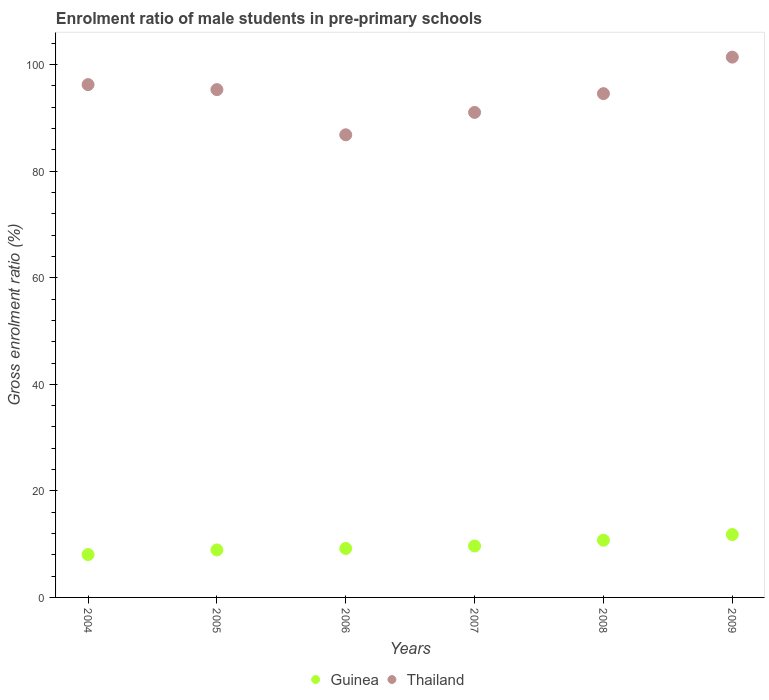How many different coloured dotlines are there?
Provide a short and direct response. 2. What is the enrolment ratio of male students in pre-primary schools in Guinea in 2007?
Offer a terse response. 9.66. Across all years, what is the maximum enrolment ratio of male students in pre-primary schools in Guinea?
Offer a terse response. 11.81. Across all years, what is the minimum enrolment ratio of male students in pre-primary schools in Guinea?
Provide a succinct answer. 8.05. What is the total enrolment ratio of male students in pre-primary schools in Thailand in the graph?
Your answer should be very brief. 565.43. What is the difference between the enrolment ratio of male students in pre-primary schools in Guinea in 2006 and that in 2009?
Offer a terse response. -2.62. What is the difference between the enrolment ratio of male students in pre-primary schools in Guinea in 2004 and the enrolment ratio of male students in pre-primary schools in Thailand in 2007?
Your answer should be compact. -82.99. What is the average enrolment ratio of male students in pre-primary schools in Thailand per year?
Offer a terse response. 94.24. In the year 2007, what is the difference between the enrolment ratio of male students in pre-primary schools in Thailand and enrolment ratio of male students in pre-primary schools in Guinea?
Keep it short and to the point. 81.38. In how many years, is the enrolment ratio of male students in pre-primary schools in Thailand greater than 44 %?
Ensure brevity in your answer.  6. What is the ratio of the enrolment ratio of male students in pre-primary schools in Guinea in 2006 to that in 2008?
Your response must be concise. 0.86. What is the difference between the highest and the second highest enrolment ratio of male students in pre-primary schools in Guinea?
Make the answer very short. 1.07. What is the difference between the highest and the lowest enrolment ratio of male students in pre-primary schools in Guinea?
Offer a terse response. 3.76. Is the enrolment ratio of male students in pre-primary schools in Thailand strictly less than the enrolment ratio of male students in pre-primary schools in Guinea over the years?
Your response must be concise. No. What is the difference between two consecutive major ticks on the Y-axis?
Provide a short and direct response. 20. What is the title of the graph?
Provide a succinct answer. Enrolment ratio of male students in pre-primary schools. What is the label or title of the Y-axis?
Keep it short and to the point. Gross enrolment ratio (%). What is the Gross enrolment ratio (%) in Guinea in 2004?
Provide a short and direct response. 8.05. What is the Gross enrolment ratio (%) of Thailand in 2004?
Provide a succinct answer. 96.26. What is the Gross enrolment ratio (%) in Guinea in 2005?
Provide a succinct answer. 8.92. What is the Gross enrolment ratio (%) in Thailand in 2005?
Your answer should be compact. 95.32. What is the Gross enrolment ratio (%) in Guinea in 2006?
Provide a succinct answer. 9.19. What is the Gross enrolment ratio (%) in Thailand in 2006?
Offer a terse response. 86.84. What is the Gross enrolment ratio (%) in Guinea in 2007?
Provide a short and direct response. 9.66. What is the Gross enrolment ratio (%) in Thailand in 2007?
Offer a very short reply. 91.04. What is the Gross enrolment ratio (%) in Guinea in 2008?
Provide a short and direct response. 10.74. What is the Gross enrolment ratio (%) in Thailand in 2008?
Your answer should be very brief. 94.56. What is the Gross enrolment ratio (%) of Guinea in 2009?
Your answer should be very brief. 11.81. What is the Gross enrolment ratio (%) in Thailand in 2009?
Ensure brevity in your answer.  101.42. Across all years, what is the maximum Gross enrolment ratio (%) in Guinea?
Give a very brief answer. 11.81. Across all years, what is the maximum Gross enrolment ratio (%) of Thailand?
Your answer should be compact. 101.42. Across all years, what is the minimum Gross enrolment ratio (%) of Guinea?
Your answer should be compact. 8.05. Across all years, what is the minimum Gross enrolment ratio (%) of Thailand?
Keep it short and to the point. 86.84. What is the total Gross enrolment ratio (%) in Guinea in the graph?
Your response must be concise. 58.35. What is the total Gross enrolment ratio (%) of Thailand in the graph?
Provide a succinct answer. 565.43. What is the difference between the Gross enrolment ratio (%) of Guinea in 2004 and that in 2005?
Your response must be concise. -0.87. What is the difference between the Gross enrolment ratio (%) in Thailand in 2004 and that in 2005?
Your answer should be compact. 0.94. What is the difference between the Gross enrolment ratio (%) of Guinea in 2004 and that in 2006?
Give a very brief answer. -1.14. What is the difference between the Gross enrolment ratio (%) in Thailand in 2004 and that in 2006?
Your answer should be compact. 9.42. What is the difference between the Gross enrolment ratio (%) in Guinea in 2004 and that in 2007?
Give a very brief answer. -1.61. What is the difference between the Gross enrolment ratio (%) in Thailand in 2004 and that in 2007?
Provide a short and direct response. 5.22. What is the difference between the Gross enrolment ratio (%) of Guinea in 2004 and that in 2008?
Offer a terse response. -2.69. What is the difference between the Gross enrolment ratio (%) of Thailand in 2004 and that in 2008?
Offer a terse response. 1.7. What is the difference between the Gross enrolment ratio (%) in Guinea in 2004 and that in 2009?
Your answer should be very brief. -3.76. What is the difference between the Gross enrolment ratio (%) of Thailand in 2004 and that in 2009?
Ensure brevity in your answer.  -5.16. What is the difference between the Gross enrolment ratio (%) of Guinea in 2005 and that in 2006?
Your answer should be very brief. -0.27. What is the difference between the Gross enrolment ratio (%) of Thailand in 2005 and that in 2006?
Provide a short and direct response. 8.48. What is the difference between the Gross enrolment ratio (%) in Guinea in 2005 and that in 2007?
Ensure brevity in your answer.  -0.74. What is the difference between the Gross enrolment ratio (%) of Thailand in 2005 and that in 2007?
Offer a terse response. 4.28. What is the difference between the Gross enrolment ratio (%) in Guinea in 2005 and that in 2008?
Your answer should be very brief. -1.82. What is the difference between the Gross enrolment ratio (%) of Thailand in 2005 and that in 2008?
Your response must be concise. 0.76. What is the difference between the Gross enrolment ratio (%) in Guinea in 2005 and that in 2009?
Give a very brief answer. -2.89. What is the difference between the Gross enrolment ratio (%) of Thailand in 2005 and that in 2009?
Offer a very short reply. -6.1. What is the difference between the Gross enrolment ratio (%) of Guinea in 2006 and that in 2007?
Keep it short and to the point. -0.47. What is the difference between the Gross enrolment ratio (%) of Thailand in 2006 and that in 2007?
Your answer should be compact. -4.2. What is the difference between the Gross enrolment ratio (%) in Guinea in 2006 and that in 2008?
Keep it short and to the point. -1.55. What is the difference between the Gross enrolment ratio (%) in Thailand in 2006 and that in 2008?
Your answer should be very brief. -7.73. What is the difference between the Gross enrolment ratio (%) in Guinea in 2006 and that in 2009?
Ensure brevity in your answer.  -2.62. What is the difference between the Gross enrolment ratio (%) of Thailand in 2006 and that in 2009?
Offer a very short reply. -14.58. What is the difference between the Gross enrolment ratio (%) of Guinea in 2007 and that in 2008?
Ensure brevity in your answer.  -1.08. What is the difference between the Gross enrolment ratio (%) of Thailand in 2007 and that in 2008?
Keep it short and to the point. -3.52. What is the difference between the Gross enrolment ratio (%) in Guinea in 2007 and that in 2009?
Provide a succinct answer. -2.15. What is the difference between the Gross enrolment ratio (%) of Thailand in 2007 and that in 2009?
Give a very brief answer. -10.38. What is the difference between the Gross enrolment ratio (%) of Guinea in 2008 and that in 2009?
Ensure brevity in your answer.  -1.07. What is the difference between the Gross enrolment ratio (%) of Thailand in 2008 and that in 2009?
Ensure brevity in your answer.  -6.85. What is the difference between the Gross enrolment ratio (%) in Guinea in 2004 and the Gross enrolment ratio (%) in Thailand in 2005?
Provide a succinct answer. -87.27. What is the difference between the Gross enrolment ratio (%) of Guinea in 2004 and the Gross enrolment ratio (%) of Thailand in 2006?
Provide a short and direct response. -78.79. What is the difference between the Gross enrolment ratio (%) in Guinea in 2004 and the Gross enrolment ratio (%) in Thailand in 2007?
Offer a terse response. -82.99. What is the difference between the Gross enrolment ratio (%) in Guinea in 2004 and the Gross enrolment ratio (%) in Thailand in 2008?
Your answer should be very brief. -86.52. What is the difference between the Gross enrolment ratio (%) in Guinea in 2004 and the Gross enrolment ratio (%) in Thailand in 2009?
Your response must be concise. -93.37. What is the difference between the Gross enrolment ratio (%) in Guinea in 2005 and the Gross enrolment ratio (%) in Thailand in 2006?
Your answer should be very brief. -77.92. What is the difference between the Gross enrolment ratio (%) of Guinea in 2005 and the Gross enrolment ratio (%) of Thailand in 2007?
Provide a succinct answer. -82.12. What is the difference between the Gross enrolment ratio (%) in Guinea in 2005 and the Gross enrolment ratio (%) in Thailand in 2008?
Provide a succinct answer. -85.64. What is the difference between the Gross enrolment ratio (%) in Guinea in 2005 and the Gross enrolment ratio (%) in Thailand in 2009?
Your response must be concise. -92.5. What is the difference between the Gross enrolment ratio (%) in Guinea in 2006 and the Gross enrolment ratio (%) in Thailand in 2007?
Provide a short and direct response. -81.85. What is the difference between the Gross enrolment ratio (%) of Guinea in 2006 and the Gross enrolment ratio (%) of Thailand in 2008?
Your response must be concise. -85.38. What is the difference between the Gross enrolment ratio (%) of Guinea in 2006 and the Gross enrolment ratio (%) of Thailand in 2009?
Offer a terse response. -92.23. What is the difference between the Gross enrolment ratio (%) of Guinea in 2007 and the Gross enrolment ratio (%) of Thailand in 2008?
Your answer should be compact. -84.9. What is the difference between the Gross enrolment ratio (%) of Guinea in 2007 and the Gross enrolment ratio (%) of Thailand in 2009?
Provide a succinct answer. -91.76. What is the difference between the Gross enrolment ratio (%) of Guinea in 2008 and the Gross enrolment ratio (%) of Thailand in 2009?
Offer a terse response. -90.68. What is the average Gross enrolment ratio (%) in Guinea per year?
Provide a short and direct response. 9.72. What is the average Gross enrolment ratio (%) in Thailand per year?
Make the answer very short. 94.24. In the year 2004, what is the difference between the Gross enrolment ratio (%) of Guinea and Gross enrolment ratio (%) of Thailand?
Your response must be concise. -88.21. In the year 2005, what is the difference between the Gross enrolment ratio (%) of Guinea and Gross enrolment ratio (%) of Thailand?
Provide a short and direct response. -86.4. In the year 2006, what is the difference between the Gross enrolment ratio (%) of Guinea and Gross enrolment ratio (%) of Thailand?
Your answer should be very brief. -77.65. In the year 2007, what is the difference between the Gross enrolment ratio (%) in Guinea and Gross enrolment ratio (%) in Thailand?
Your response must be concise. -81.38. In the year 2008, what is the difference between the Gross enrolment ratio (%) in Guinea and Gross enrolment ratio (%) in Thailand?
Make the answer very short. -83.82. In the year 2009, what is the difference between the Gross enrolment ratio (%) of Guinea and Gross enrolment ratio (%) of Thailand?
Make the answer very short. -89.61. What is the ratio of the Gross enrolment ratio (%) in Guinea in 2004 to that in 2005?
Ensure brevity in your answer.  0.9. What is the ratio of the Gross enrolment ratio (%) of Thailand in 2004 to that in 2005?
Your answer should be compact. 1.01. What is the ratio of the Gross enrolment ratio (%) of Guinea in 2004 to that in 2006?
Make the answer very short. 0.88. What is the ratio of the Gross enrolment ratio (%) in Thailand in 2004 to that in 2006?
Keep it short and to the point. 1.11. What is the ratio of the Gross enrolment ratio (%) in Guinea in 2004 to that in 2007?
Provide a short and direct response. 0.83. What is the ratio of the Gross enrolment ratio (%) of Thailand in 2004 to that in 2007?
Make the answer very short. 1.06. What is the ratio of the Gross enrolment ratio (%) in Guinea in 2004 to that in 2008?
Provide a short and direct response. 0.75. What is the ratio of the Gross enrolment ratio (%) in Thailand in 2004 to that in 2008?
Offer a terse response. 1.02. What is the ratio of the Gross enrolment ratio (%) in Guinea in 2004 to that in 2009?
Provide a succinct answer. 0.68. What is the ratio of the Gross enrolment ratio (%) in Thailand in 2004 to that in 2009?
Offer a very short reply. 0.95. What is the ratio of the Gross enrolment ratio (%) of Guinea in 2005 to that in 2006?
Provide a succinct answer. 0.97. What is the ratio of the Gross enrolment ratio (%) in Thailand in 2005 to that in 2006?
Keep it short and to the point. 1.1. What is the ratio of the Gross enrolment ratio (%) of Guinea in 2005 to that in 2007?
Offer a terse response. 0.92. What is the ratio of the Gross enrolment ratio (%) of Thailand in 2005 to that in 2007?
Your response must be concise. 1.05. What is the ratio of the Gross enrolment ratio (%) of Guinea in 2005 to that in 2008?
Ensure brevity in your answer.  0.83. What is the ratio of the Gross enrolment ratio (%) of Thailand in 2005 to that in 2008?
Your response must be concise. 1.01. What is the ratio of the Gross enrolment ratio (%) in Guinea in 2005 to that in 2009?
Make the answer very short. 0.76. What is the ratio of the Gross enrolment ratio (%) in Thailand in 2005 to that in 2009?
Provide a succinct answer. 0.94. What is the ratio of the Gross enrolment ratio (%) in Guinea in 2006 to that in 2007?
Offer a very short reply. 0.95. What is the ratio of the Gross enrolment ratio (%) in Thailand in 2006 to that in 2007?
Make the answer very short. 0.95. What is the ratio of the Gross enrolment ratio (%) in Guinea in 2006 to that in 2008?
Your answer should be compact. 0.86. What is the ratio of the Gross enrolment ratio (%) of Thailand in 2006 to that in 2008?
Provide a short and direct response. 0.92. What is the ratio of the Gross enrolment ratio (%) of Guinea in 2006 to that in 2009?
Your response must be concise. 0.78. What is the ratio of the Gross enrolment ratio (%) in Thailand in 2006 to that in 2009?
Offer a very short reply. 0.86. What is the ratio of the Gross enrolment ratio (%) in Guinea in 2007 to that in 2008?
Ensure brevity in your answer.  0.9. What is the ratio of the Gross enrolment ratio (%) of Thailand in 2007 to that in 2008?
Give a very brief answer. 0.96. What is the ratio of the Gross enrolment ratio (%) in Guinea in 2007 to that in 2009?
Provide a short and direct response. 0.82. What is the ratio of the Gross enrolment ratio (%) of Thailand in 2007 to that in 2009?
Make the answer very short. 0.9. What is the ratio of the Gross enrolment ratio (%) in Guinea in 2008 to that in 2009?
Keep it short and to the point. 0.91. What is the ratio of the Gross enrolment ratio (%) of Thailand in 2008 to that in 2009?
Your answer should be very brief. 0.93. What is the difference between the highest and the second highest Gross enrolment ratio (%) in Guinea?
Ensure brevity in your answer.  1.07. What is the difference between the highest and the second highest Gross enrolment ratio (%) of Thailand?
Make the answer very short. 5.16. What is the difference between the highest and the lowest Gross enrolment ratio (%) in Guinea?
Keep it short and to the point. 3.76. What is the difference between the highest and the lowest Gross enrolment ratio (%) of Thailand?
Your response must be concise. 14.58. 